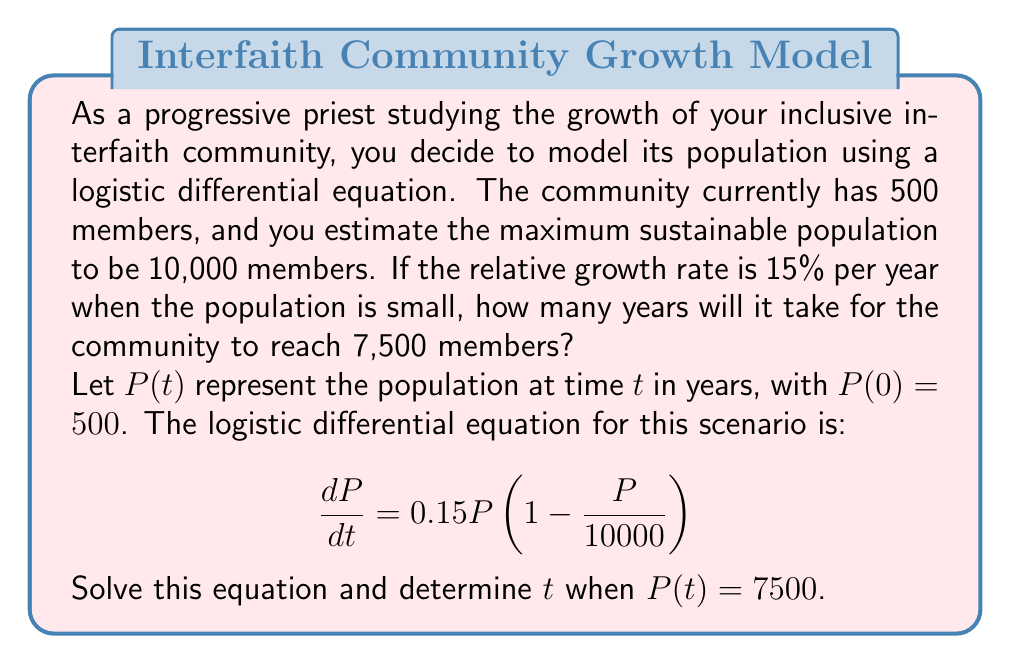Provide a solution to this math problem. To solve this problem, we'll follow these steps:

1) The general solution to the logistic differential equation is:

   $$P(t) = \frac{K}{1 + Ce^{-rt}}$$

   where $K$ is the carrying capacity, $r$ is the growth rate, and $C$ is a constant.

2) We know $K = 10000$ and $r = 0.15$. We need to find $C$ using the initial condition $P(0) = 500$:

   $$500 = \frac{10000}{1 + C}$$
   $$C = 19$$

3) So our specific solution is:

   $$P(t) = \frac{10000}{1 + 19e^{-0.15t}}$$

4) Now we need to solve for $t$ when $P(t) = 7500$:

   $$7500 = \frac{10000}{1 + 19e^{-0.15t}}$$

5) Simplifying:
   
   $$1 + 19e^{-0.15t} = \frac{10000}{7500} = \frac{4}{3}$$
   $$19e^{-0.15t} = \frac{1}{3}$$
   $$e^{-0.15t} = \frac{1}{57}$$

6) Taking the natural log of both sides:

   $$-0.15t = \ln(\frac{1}{57})$$
   $$t = -\frac{1}{0.15}\ln(\frac{1}{57}) \approx 27.21$$

Therefore, it will take approximately 27.21 years for the community to reach 7,500 members.
Answer: 27.21 years 